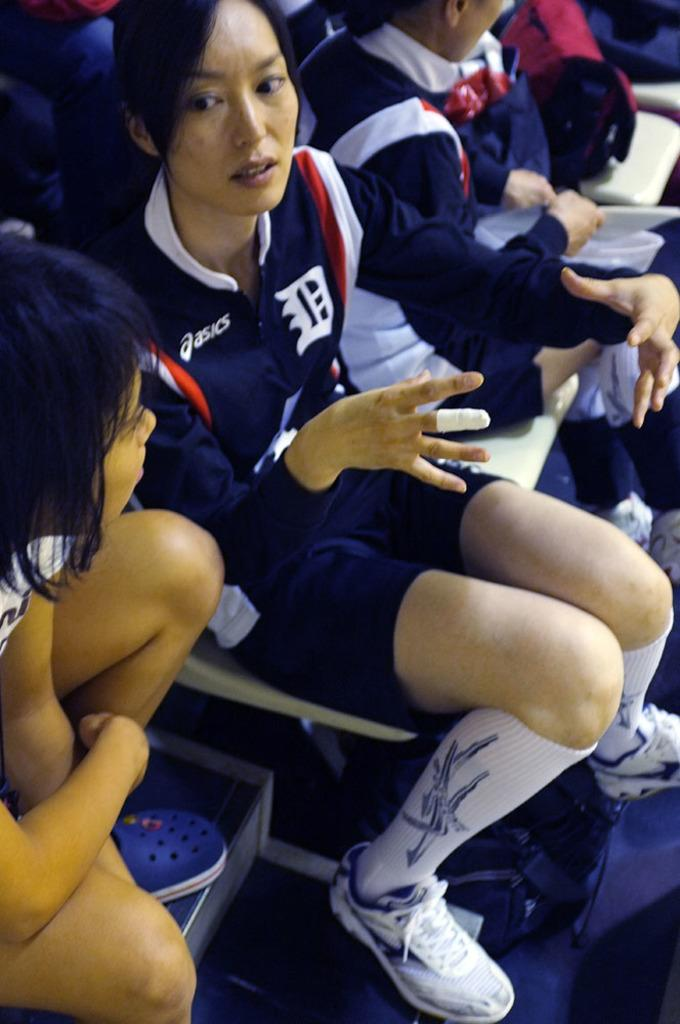<image>
Summarize the visual content of the image. An Asian female athlete is sitting down and gesturing while wearing sports clothing with the Asics and a D logo. 